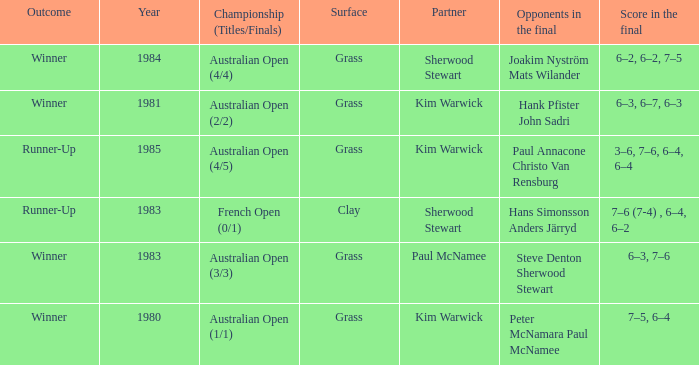What championship was played in 1981? Australian Open (2/2). 